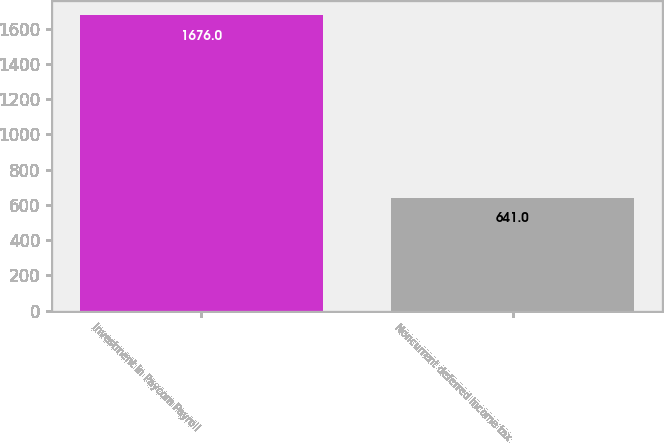Convert chart. <chart><loc_0><loc_0><loc_500><loc_500><bar_chart><fcel>Investment in Paycom Payroll<fcel>Noncurrent deferred income tax<nl><fcel>1676<fcel>641<nl></chart> 